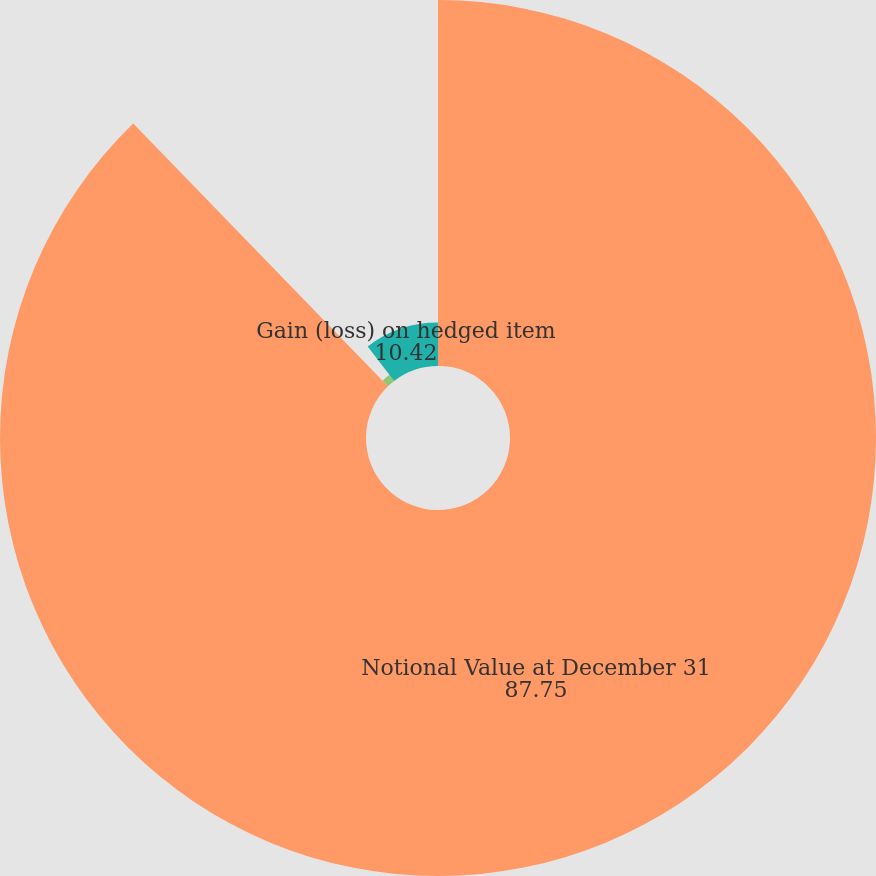Convert chart to OTSL. <chart><loc_0><loc_0><loc_500><loc_500><pie_chart><fcel>Notional Value at December 31<fcel>Gain (loss) on instrument<fcel>Gain (loss) on hedged item<nl><fcel>87.75%<fcel>1.83%<fcel>10.42%<nl></chart> 